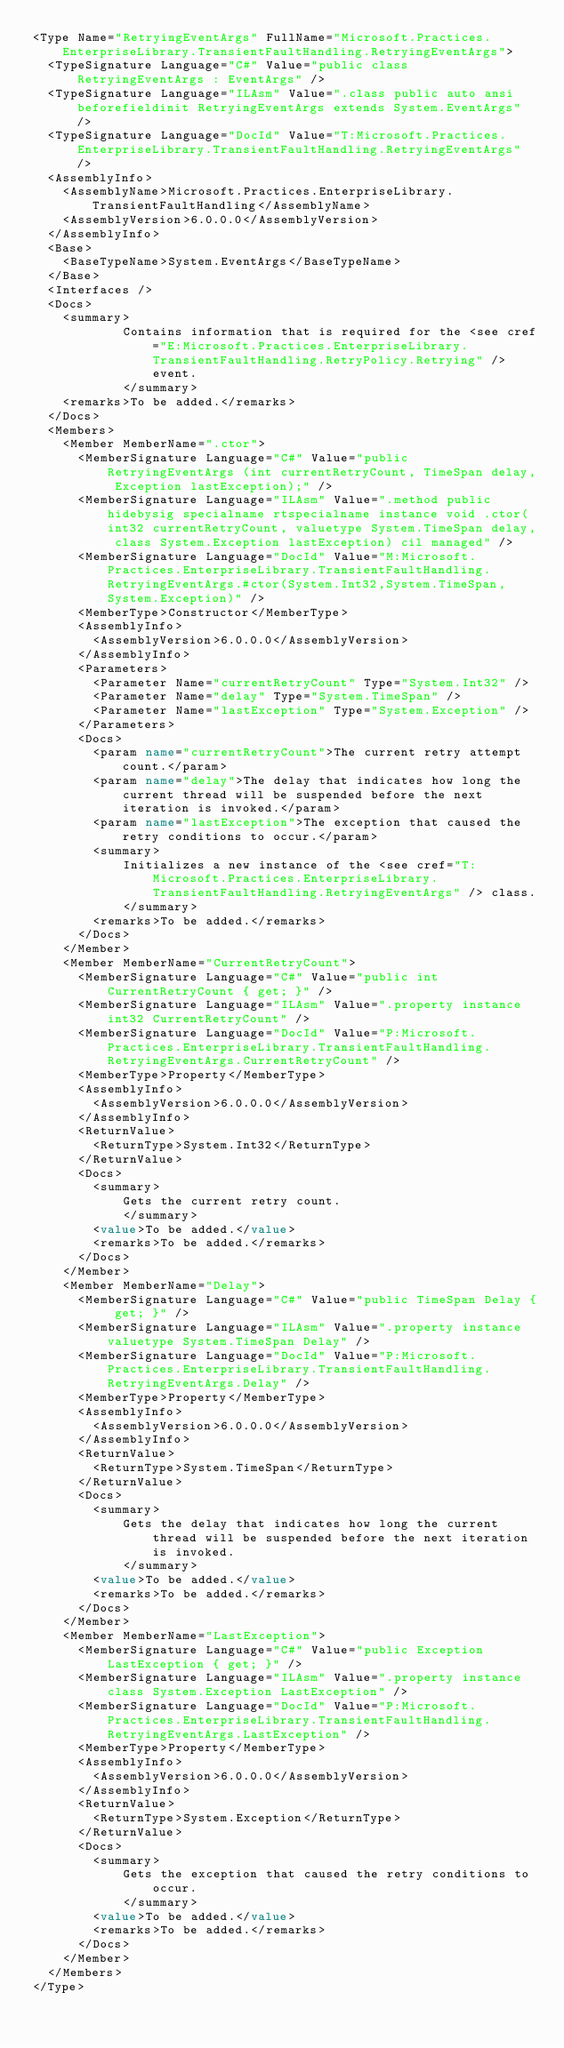<code> <loc_0><loc_0><loc_500><loc_500><_XML_><Type Name="RetryingEventArgs" FullName="Microsoft.Practices.EnterpriseLibrary.TransientFaultHandling.RetryingEventArgs">
  <TypeSignature Language="C#" Value="public class RetryingEventArgs : EventArgs" />
  <TypeSignature Language="ILAsm" Value=".class public auto ansi beforefieldinit RetryingEventArgs extends System.EventArgs" />
  <TypeSignature Language="DocId" Value="T:Microsoft.Practices.EnterpriseLibrary.TransientFaultHandling.RetryingEventArgs" />
  <AssemblyInfo>
    <AssemblyName>Microsoft.Practices.EnterpriseLibrary.TransientFaultHandling</AssemblyName>
    <AssemblyVersion>6.0.0.0</AssemblyVersion>
  </AssemblyInfo>
  <Base>
    <BaseTypeName>System.EventArgs</BaseTypeName>
  </Base>
  <Interfaces />
  <Docs>
    <summary>
            Contains information that is required for the <see cref="E:Microsoft.Practices.EnterpriseLibrary.TransientFaultHandling.RetryPolicy.Retrying" /> event.
            </summary>
    <remarks>To be added.</remarks>
  </Docs>
  <Members>
    <Member MemberName=".ctor">
      <MemberSignature Language="C#" Value="public RetryingEventArgs (int currentRetryCount, TimeSpan delay, Exception lastException);" />
      <MemberSignature Language="ILAsm" Value=".method public hidebysig specialname rtspecialname instance void .ctor(int32 currentRetryCount, valuetype System.TimeSpan delay, class System.Exception lastException) cil managed" />
      <MemberSignature Language="DocId" Value="M:Microsoft.Practices.EnterpriseLibrary.TransientFaultHandling.RetryingEventArgs.#ctor(System.Int32,System.TimeSpan,System.Exception)" />
      <MemberType>Constructor</MemberType>
      <AssemblyInfo>
        <AssemblyVersion>6.0.0.0</AssemblyVersion>
      </AssemblyInfo>
      <Parameters>
        <Parameter Name="currentRetryCount" Type="System.Int32" />
        <Parameter Name="delay" Type="System.TimeSpan" />
        <Parameter Name="lastException" Type="System.Exception" />
      </Parameters>
      <Docs>
        <param name="currentRetryCount">The current retry attempt count.</param>
        <param name="delay">The delay that indicates how long the current thread will be suspended before the next iteration is invoked.</param>
        <param name="lastException">The exception that caused the retry conditions to occur.</param>
        <summary>
            Initializes a new instance of the <see cref="T:Microsoft.Practices.EnterpriseLibrary.TransientFaultHandling.RetryingEventArgs" /> class.
            </summary>
        <remarks>To be added.</remarks>
      </Docs>
    </Member>
    <Member MemberName="CurrentRetryCount">
      <MemberSignature Language="C#" Value="public int CurrentRetryCount { get; }" />
      <MemberSignature Language="ILAsm" Value=".property instance int32 CurrentRetryCount" />
      <MemberSignature Language="DocId" Value="P:Microsoft.Practices.EnterpriseLibrary.TransientFaultHandling.RetryingEventArgs.CurrentRetryCount" />
      <MemberType>Property</MemberType>
      <AssemblyInfo>
        <AssemblyVersion>6.0.0.0</AssemblyVersion>
      </AssemblyInfo>
      <ReturnValue>
        <ReturnType>System.Int32</ReturnType>
      </ReturnValue>
      <Docs>
        <summary>
            Gets the current retry count.
            </summary>
        <value>To be added.</value>
        <remarks>To be added.</remarks>
      </Docs>
    </Member>
    <Member MemberName="Delay">
      <MemberSignature Language="C#" Value="public TimeSpan Delay { get; }" />
      <MemberSignature Language="ILAsm" Value=".property instance valuetype System.TimeSpan Delay" />
      <MemberSignature Language="DocId" Value="P:Microsoft.Practices.EnterpriseLibrary.TransientFaultHandling.RetryingEventArgs.Delay" />
      <MemberType>Property</MemberType>
      <AssemblyInfo>
        <AssemblyVersion>6.0.0.0</AssemblyVersion>
      </AssemblyInfo>
      <ReturnValue>
        <ReturnType>System.TimeSpan</ReturnType>
      </ReturnValue>
      <Docs>
        <summary>
            Gets the delay that indicates how long the current thread will be suspended before the next iteration is invoked.
            </summary>
        <value>To be added.</value>
        <remarks>To be added.</remarks>
      </Docs>
    </Member>
    <Member MemberName="LastException">
      <MemberSignature Language="C#" Value="public Exception LastException { get; }" />
      <MemberSignature Language="ILAsm" Value=".property instance class System.Exception LastException" />
      <MemberSignature Language="DocId" Value="P:Microsoft.Practices.EnterpriseLibrary.TransientFaultHandling.RetryingEventArgs.LastException" />
      <MemberType>Property</MemberType>
      <AssemblyInfo>
        <AssemblyVersion>6.0.0.0</AssemblyVersion>
      </AssemblyInfo>
      <ReturnValue>
        <ReturnType>System.Exception</ReturnType>
      </ReturnValue>
      <Docs>
        <summary>
            Gets the exception that caused the retry conditions to occur.
            </summary>
        <value>To be added.</value>
        <remarks>To be added.</remarks>
      </Docs>
    </Member>
  </Members>
</Type>
</code> 